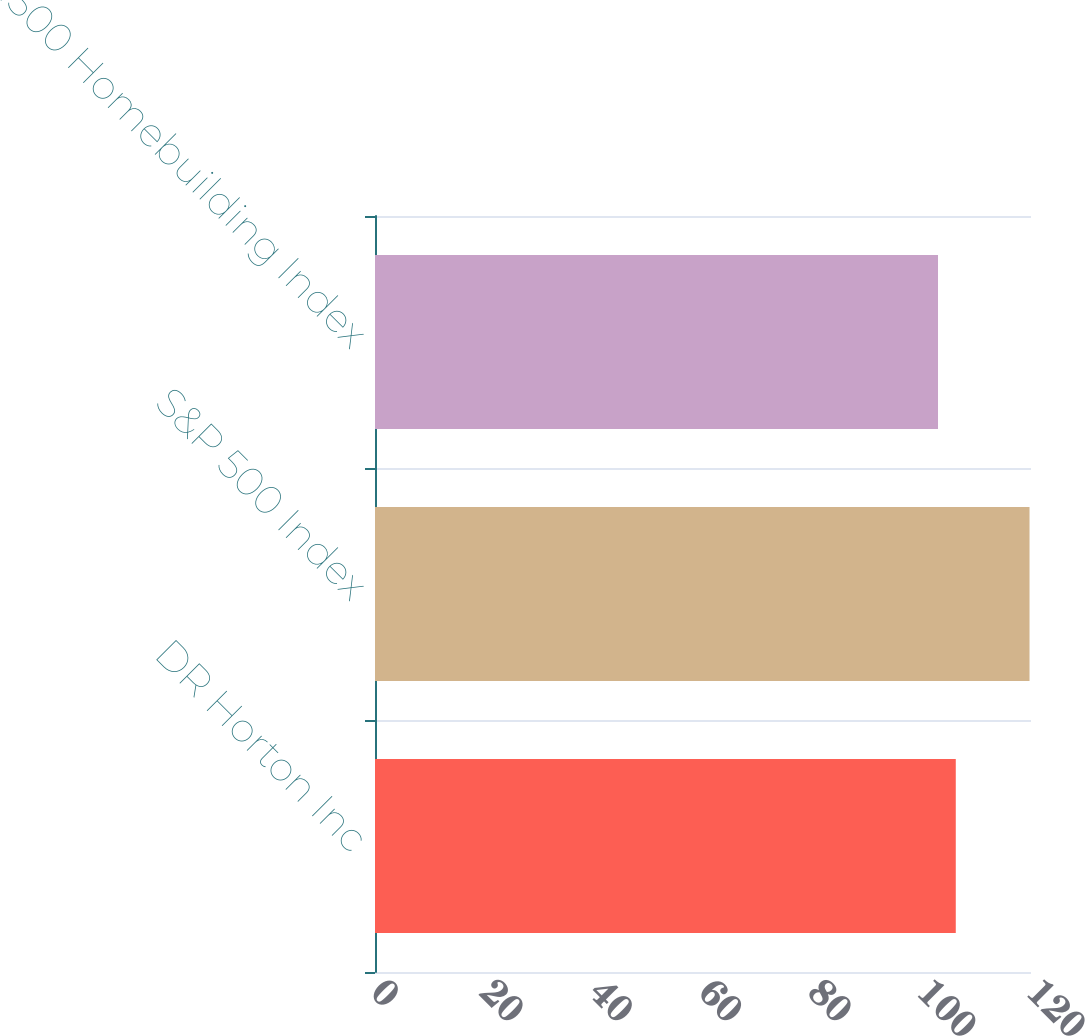Convert chart. <chart><loc_0><loc_0><loc_500><loc_500><bar_chart><fcel>DR Horton Inc<fcel>S&P 500 Index<fcel>S&P 1500 Homebuilding Index<nl><fcel>106.24<fcel>119.73<fcel>102.99<nl></chart> 